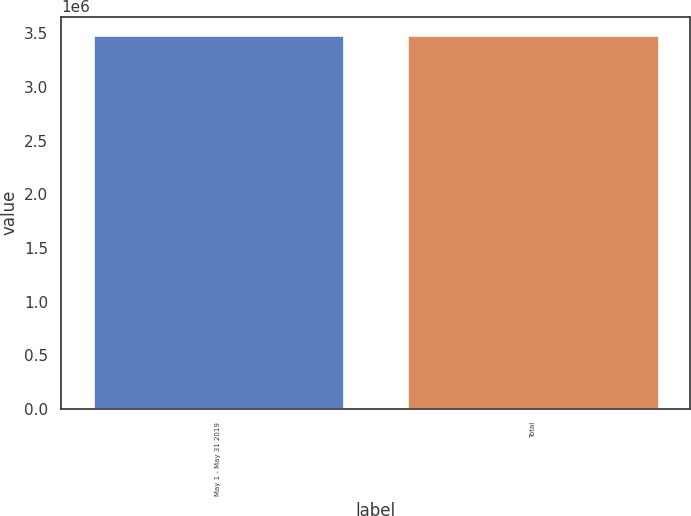Convert chart to OTSL. <chart><loc_0><loc_0><loc_500><loc_500><bar_chart><fcel>May 1 - May 31 2019<fcel>Total<nl><fcel>3.48271e+06<fcel>3.48271e+06<nl></chart> 